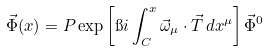<formula> <loc_0><loc_0><loc_500><loc_500>\vec { \Phi } ( x ) = P \exp \left [ \i i \int _ { C } ^ { x } \vec { \omega } _ { \mu } \cdot \vec { T } \, d x ^ { \mu } \right ] \vec { \Phi } ^ { 0 }</formula> 